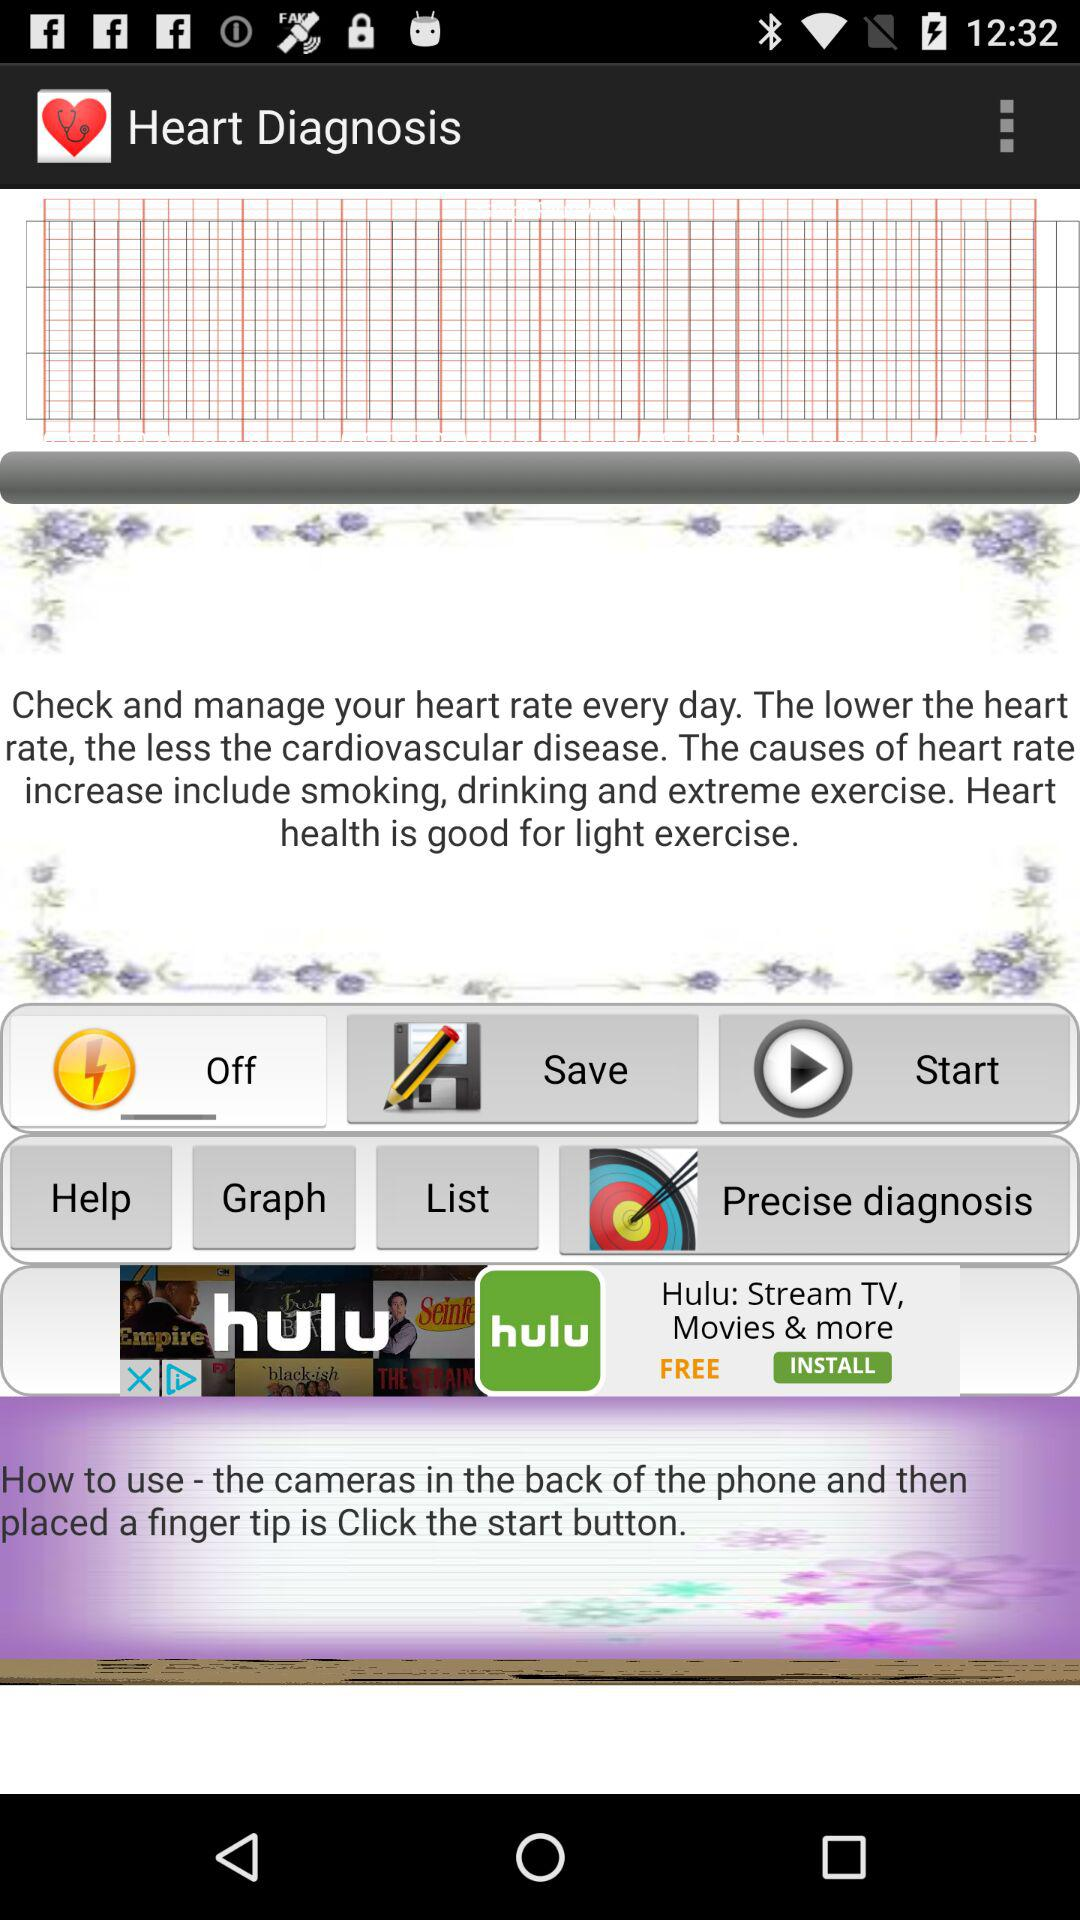What is the name of the application? The application name is "Heart Diagnosis". 